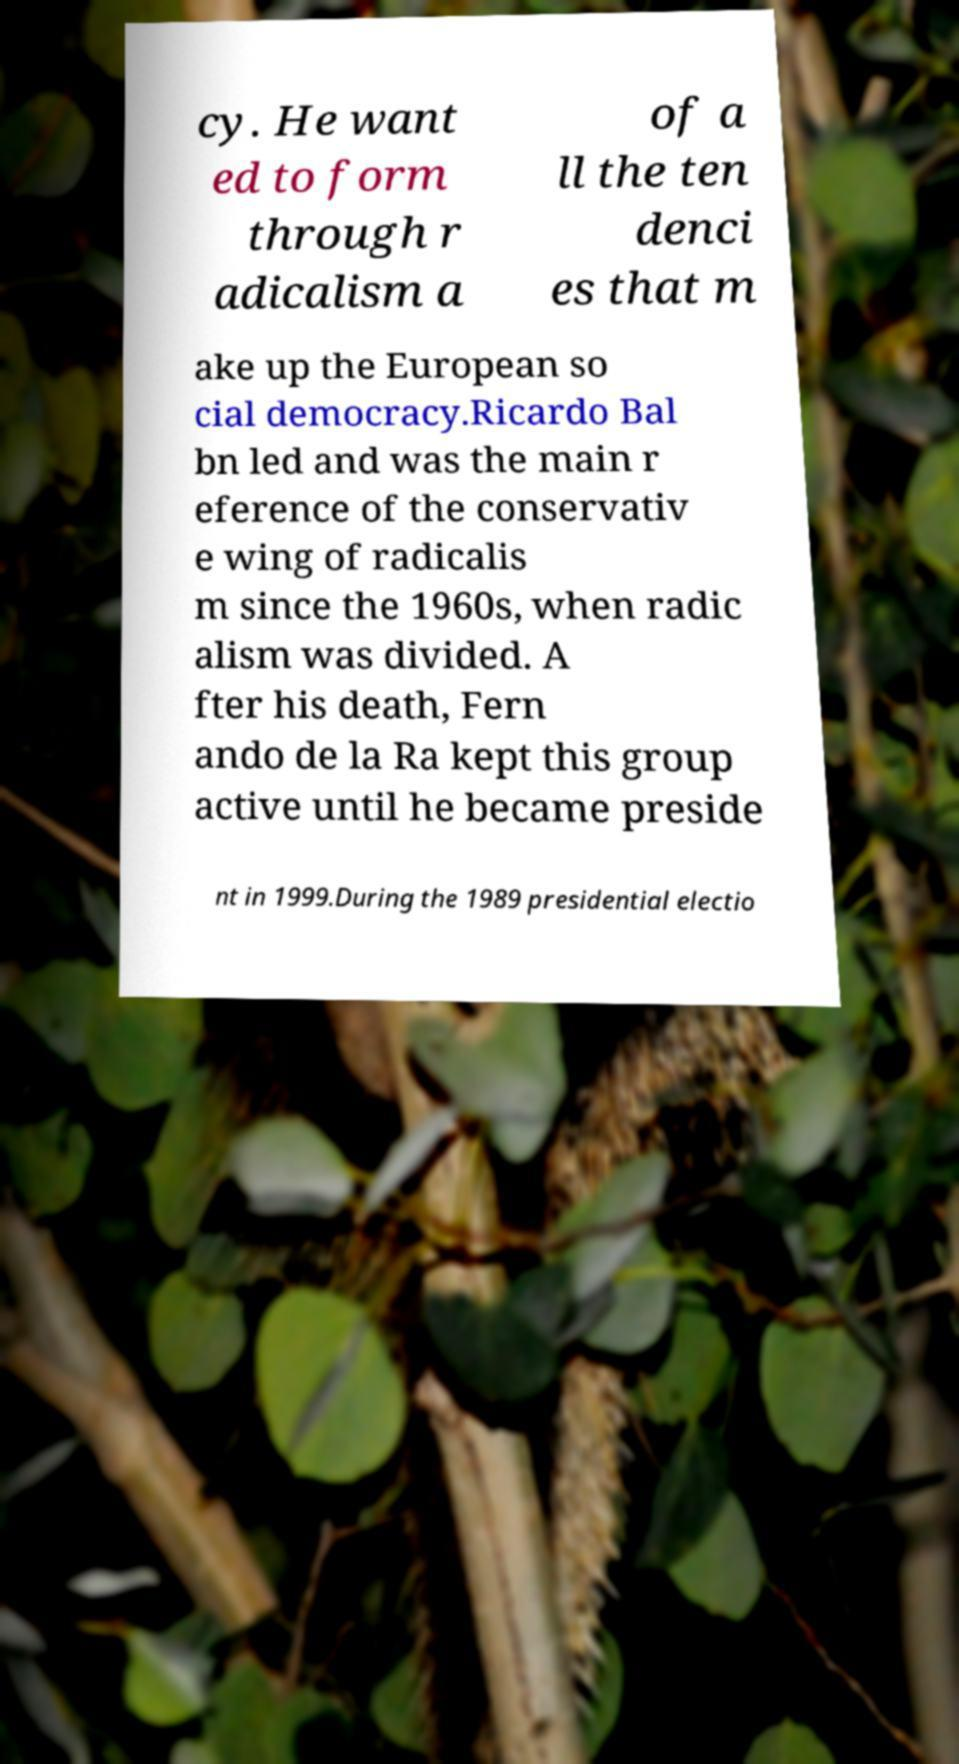Please read and relay the text visible in this image. What does it say? cy. He want ed to form through r adicalism a of a ll the ten denci es that m ake up the European so cial democracy.Ricardo Bal bn led and was the main r eference of the conservativ e wing of radicalis m since the 1960s, when radic alism was divided. A fter his death, Fern ando de la Ra kept this group active until he became preside nt in 1999.During the 1989 presidential electio 